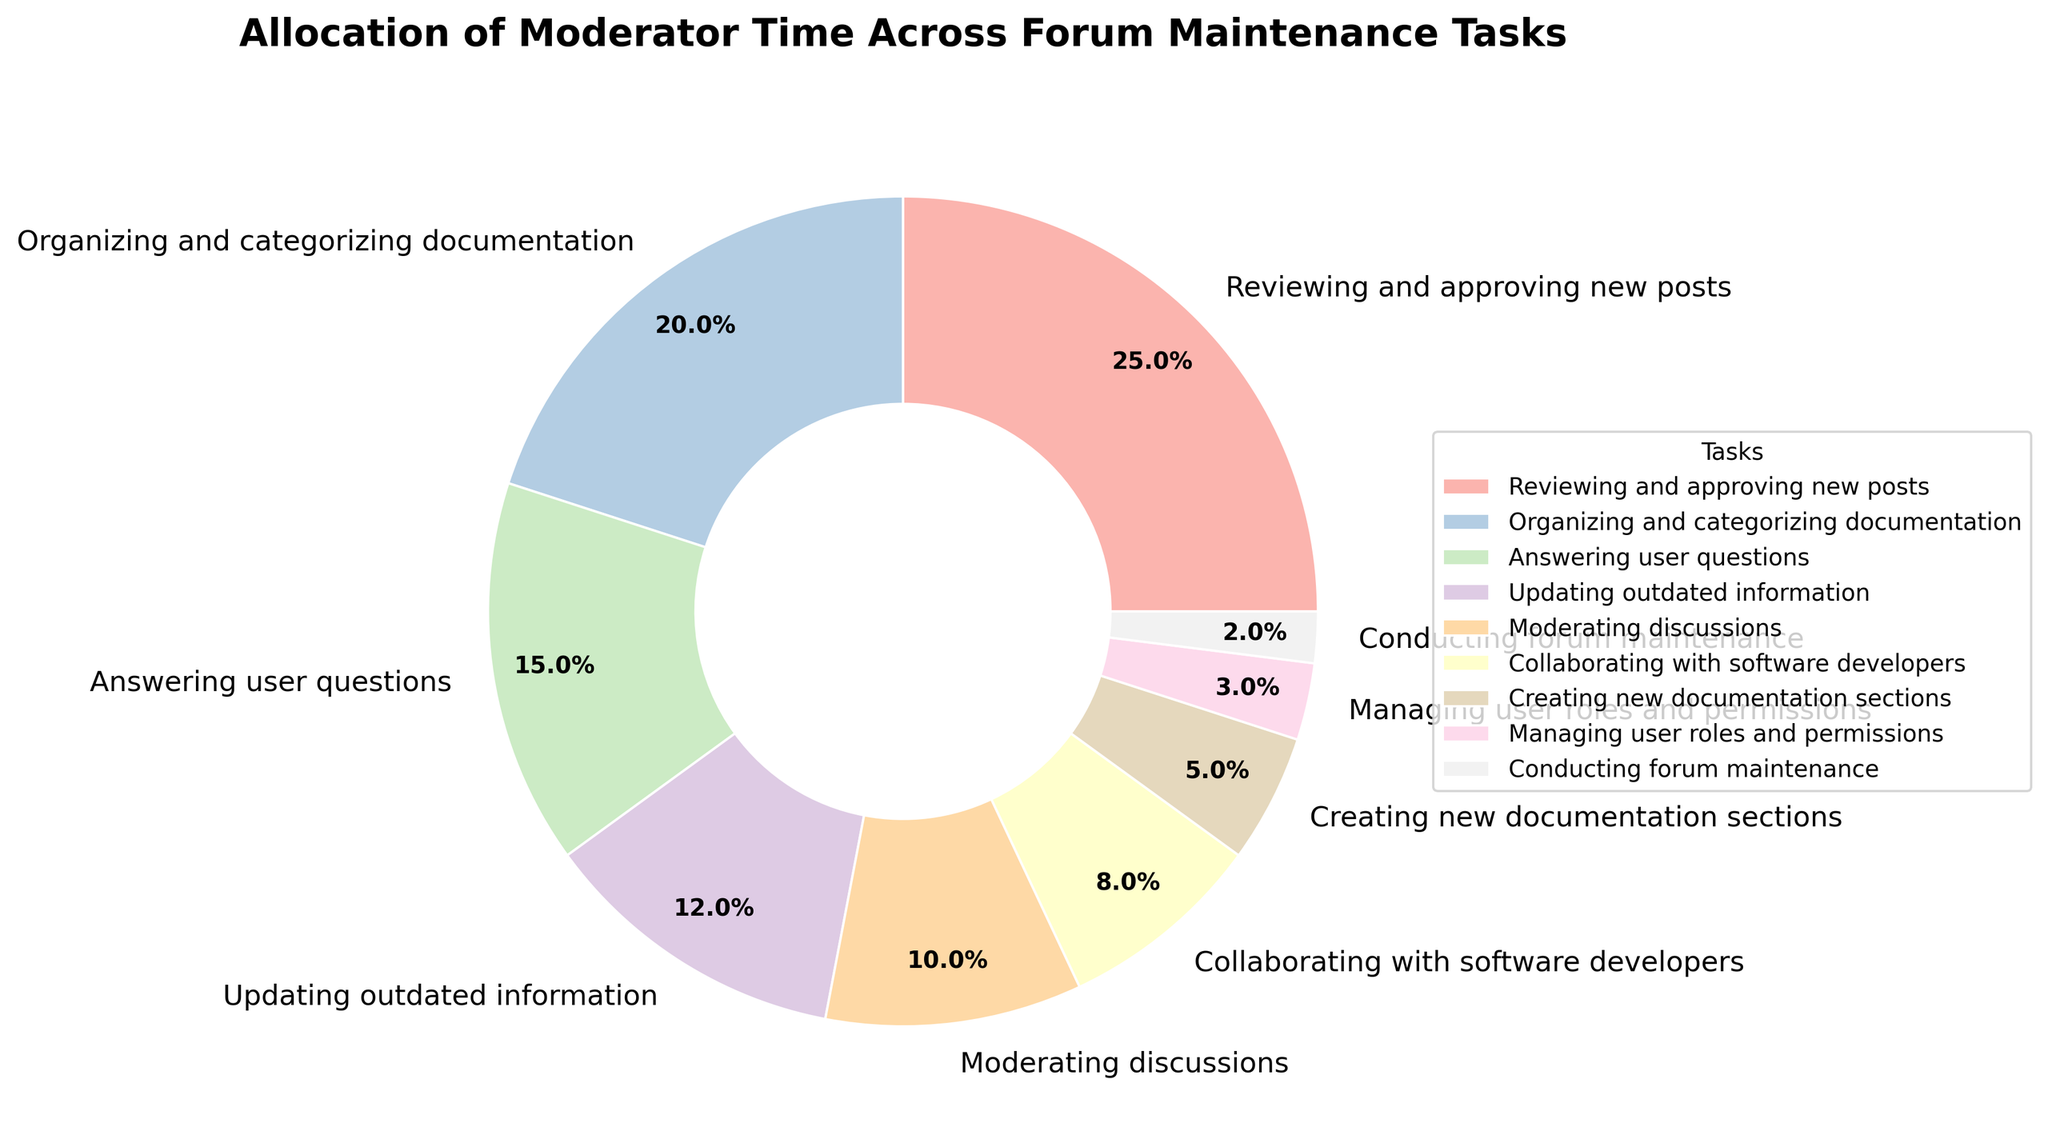What is the task where the moderators spend the highest percentage of their time? Reviewing and approving new posts covers 25% of the moderators' time, which is the largest segment on the pie chart.
Answer: Reviewing and approving new posts By how many percentage points does organizing and categorizing documentation exceed creating new documentation sections? The percentage for organizing and categorizing documentation is 20%, while creating new documentation sections is 5%. The difference is 20% - 5% = 15%.
Answer: 15% Which tasks collectively cover more time: answering user questions and moderating discussions, or collaborating with software developers and managing user roles and permissions? Answering user questions (15%) and moderating discussions (10%) together sum up to 25%. Collaborating with software developers (8%) and managing user roles and permissions (3%) together sum up to 11%. Therefore, answering user questions and moderating discussions cover more time.
Answer: Answering user questions and moderating discussions What is the percentage difference between the task with the smallest allocation and the task with the largest allocation? The smallest allocation is conducting forum maintenance at 2%, and the largest is reviewing and approving new posts at 25%. The percentage difference is 25% - 2% = 23%.
Answer: 23% Do more hours get allocated to updating outdated information or moderating discussions? Updating outdated information is allocated 12%, while moderating discussions is allocated 10%, so more hours go to updating outdated information.
Answer: Updating outdated information Which task takes up exactly 3% of the moderators' time? According to the pie chart, managing user roles and permissions takes up exactly 3% of the moderators' time.
Answer: Managing user roles and permissions Are there any two tasks combined that constitute exactly 50% of the moderator's time? Reviewing and approving new posts (25%) and organizing and categorizing documentation (20%) together make 45%, which is the highest possible combination under 50%. Thus, no two tasks together constitute exactly 50%.
Answer: No How much more time is spent on organizing documentation than on creating new documentation sections? Organizing and categorizing documentation is allocated 20%, while creating new documentation sections is allocated 5%. The additional time spent is 20% - 5% = 15%.
Answer: 15% What is the sum of the percentages for the three tasks with the lowest allocation? The three tasks with the lowest allocation are managing user roles and permissions (3%), conducting forum maintenance (2%), and creating new documentation sections (5%). The sum is 3% + 2% + 5% = 10%.
Answer: 10% 